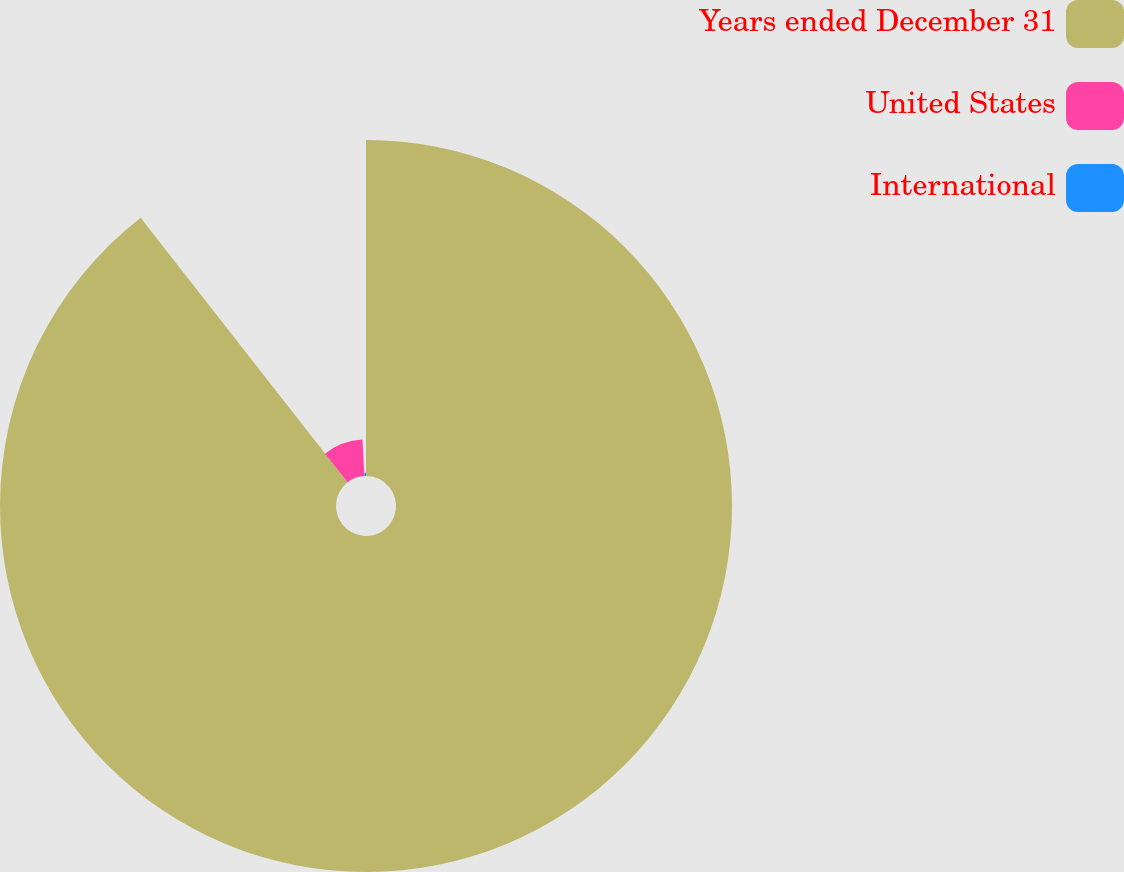Convert chart to OTSL. <chart><loc_0><loc_0><loc_500><loc_500><pie_chart><fcel>Years ended December 31<fcel>United States<fcel>International<nl><fcel>89.44%<fcel>9.71%<fcel>0.85%<nl></chart> 